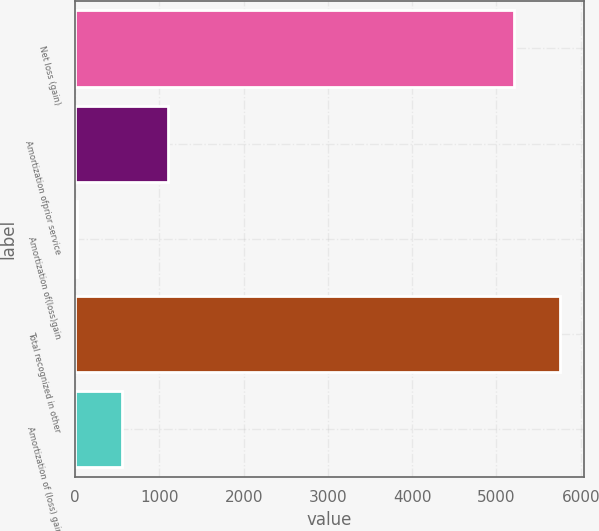Convert chart to OTSL. <chart><loc_0><loc_0><loc_500><loc_500><bar_chart><fcel>Net loss (gain)<fcel>Amortization ofprior service<fcel>Amortization of(loss)gain<fcel>Total recognized in other<fcel>Amortization of (loss) gain<nl><fcel>5209<fcel>1101.6<fcel>19<fcel>5750.3<fcel>560.3<nl></chart> 